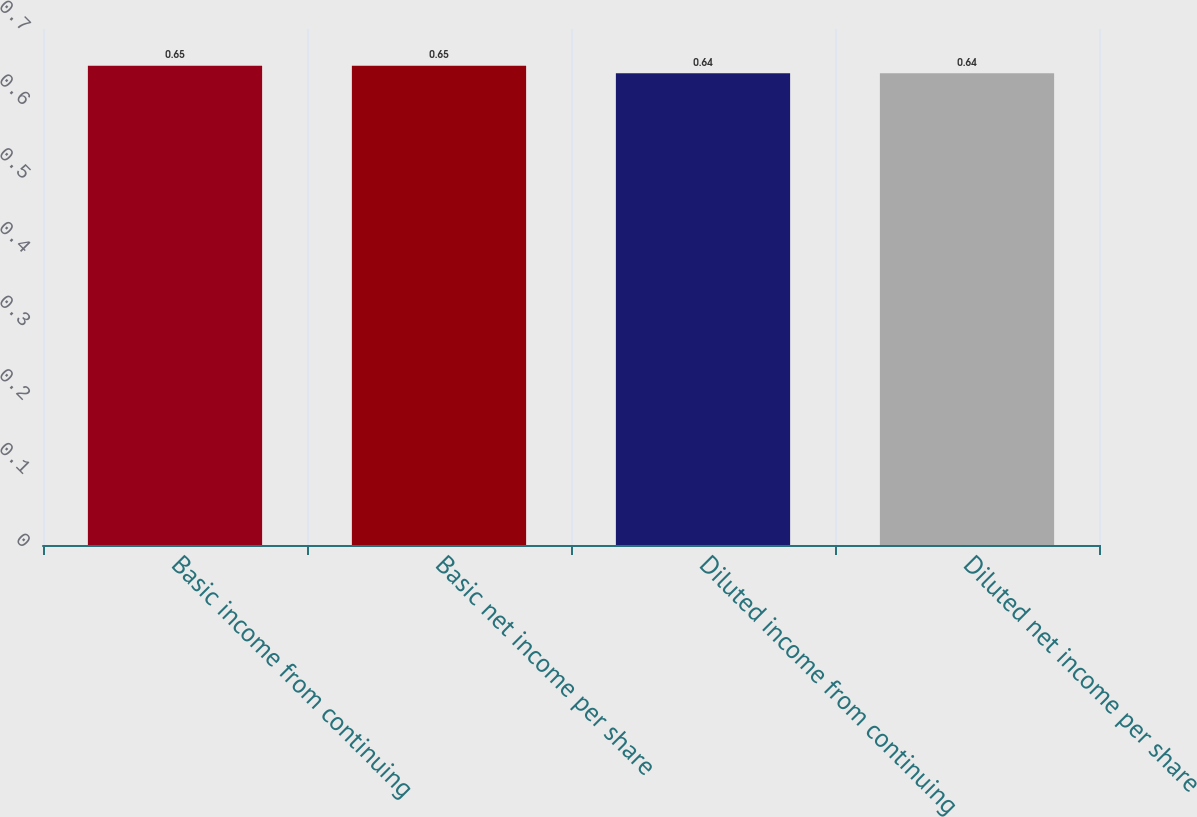Convert chart to OTSL. <chart><loc_0><loc_0><loc_500><loc_500><bar_chart><fcel>Basic income from continuing<fcel>Basic net income per share<fcel>Diluted income from continuing<fcel>Diluted net income per share<nl><fcel>0.65<fcel>0.65<fcel>0.64<fcel>0.64<nl></chart> 